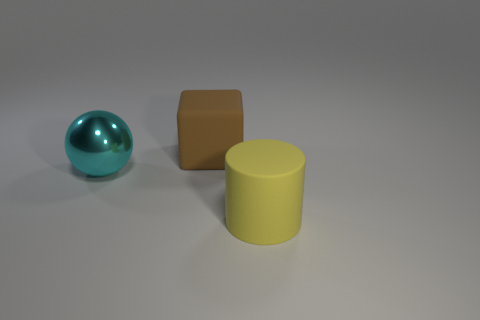Add 3 small green matte cylinders. How many objects exist? 6 Subtract all cylinders. How many objects are left? 2 Add 1 large green shiny blocks. How many large green shiny blocks exist? 1 Subtract 1 cyan spheres. How many objects are left? 2 Subtract all gray matte cylinders. Subtract all yellow rubber objects. How many objects are left? 2 Add 1 brown matte blocks. How many brown matte blocks are left? 2 